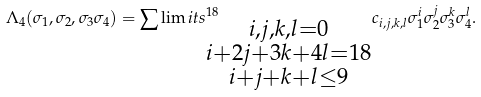Convert formula to latex. <formula><loc_0><loc_0><loc_500><loc_500>\Lambda _ { 4 } ( \sigma _ { 1 } , \sigma _ { 2 } , \sigma _ { 3 } \sigma _ { 4 } ) = \sum \lim i t s _ { \substack { i , j , k , l = 0 \\ i + 2 j + 3 k + 4 l = 1 8 \\ i + j + k + l \leq 9 } } ^ { 1 8 } c _ { i , j , k , l } \sigma _ { 1 } ^ { i } \sigma _ { 2 } ^ { j } \sigma _ { 3 } ^ { k } \sigma _ { 4 } ^ { l } .</formula> 